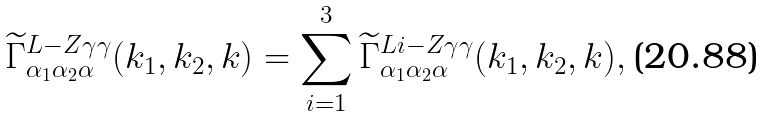<formula> <loc_0><loc_0><loc_500><loc_500>\widetilde { \Gamma } ^ { L - Z \gamma \gamma } _ { \alpha _ { 1 } \alpha _ { 2 } \alpha } ( k _ { 1 } , k _ { 2 } , k ) = \sum _ { i = 1 } ^ { 3 } \widetilde { \Gamma } ^ { L i - Z \gamma \gamma } _ { \alpha _ { 1 } \alpha _ { 2 } \alpha } ( k _ { 1 } , k _ { 2 } , k ) ,</formula> 